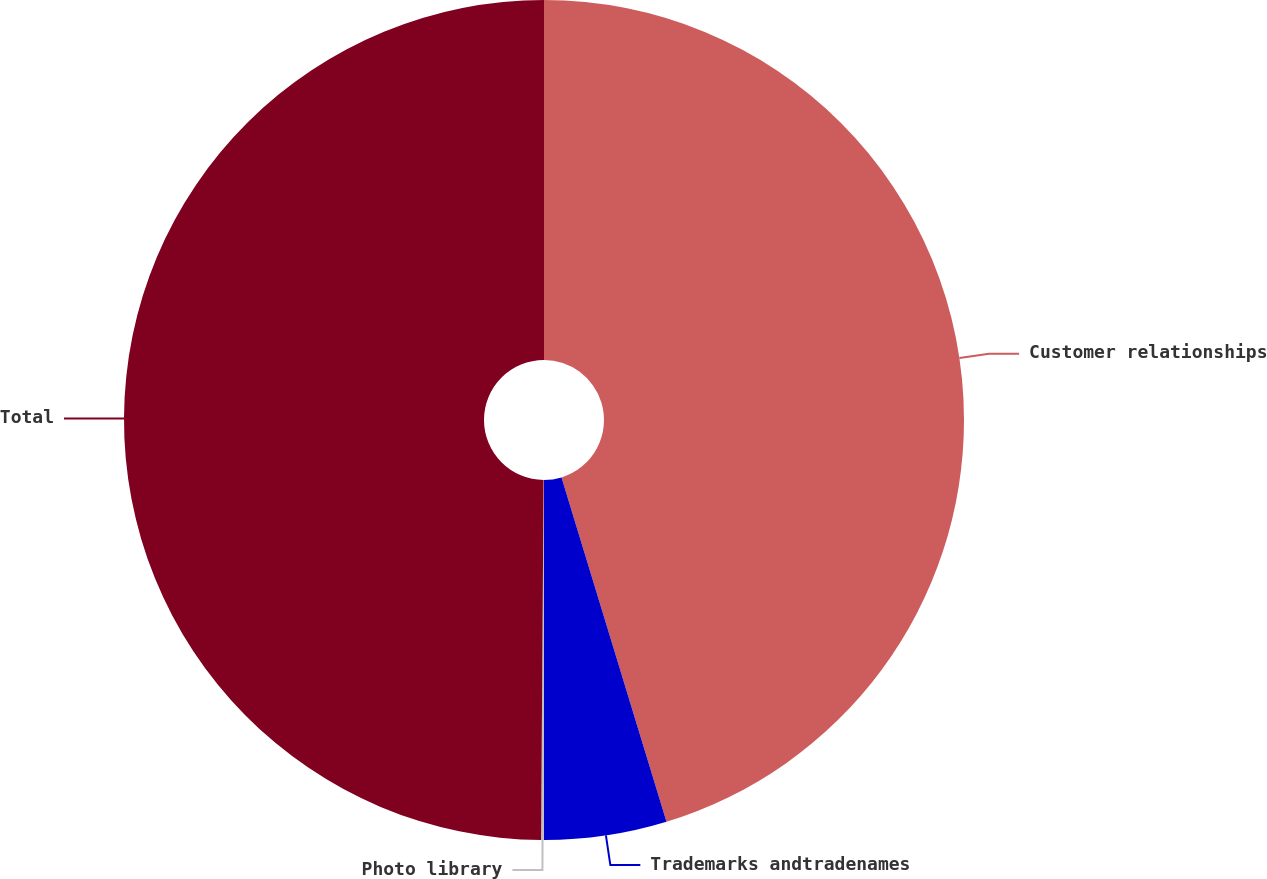Convert chart to OTSL. <chart><loc_0><loc_0><loc_500><loc_500><pie_chart><fcel>Customer relationships<fcel>Trademarks andtradenames<fcel>Photo library<fcel>Total<nl><fcel>45.29%<fcel>4.71%<fcel>0.11%<fcel>49.89%<nl></chart> 